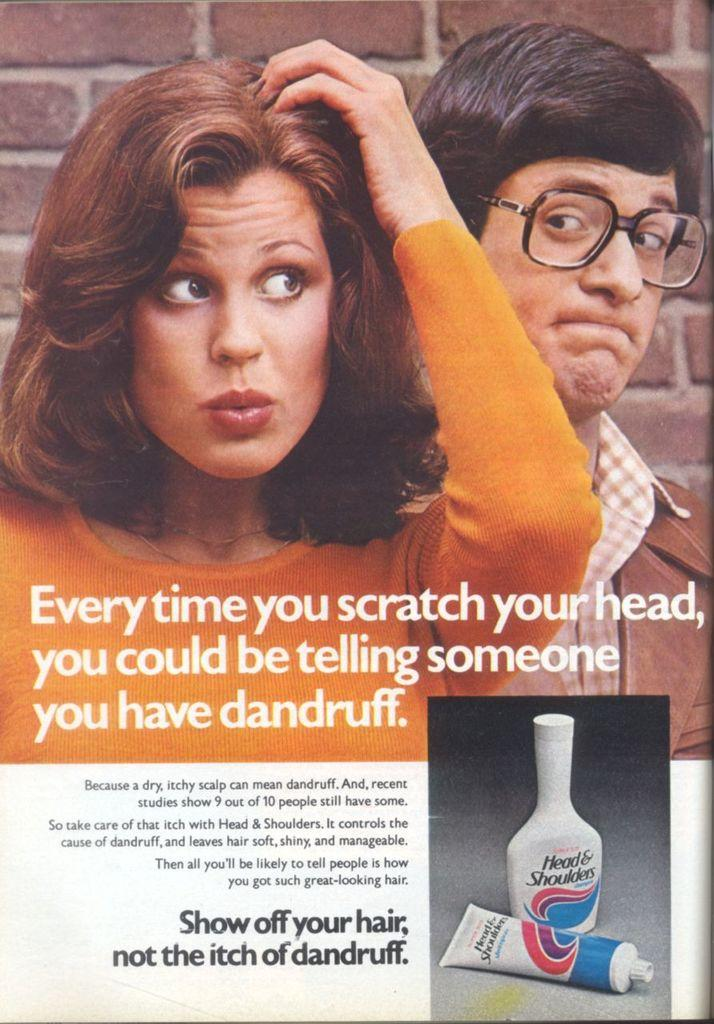<image>
Relay a brief, clear account of the picture shown. an old ad for Head and Shoulders shampoo with a woman scratching her head 